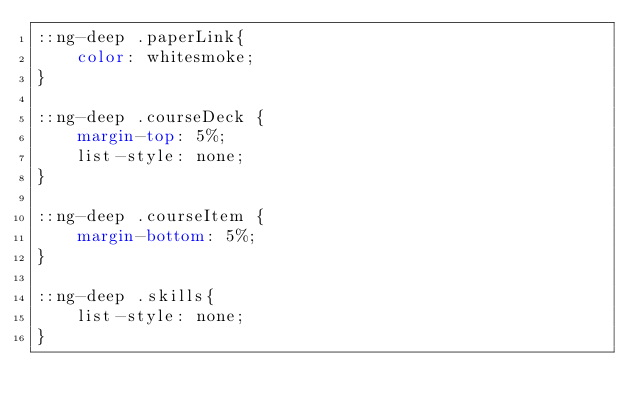<code> <loc_0><loc_0><loc_500><loc_500><_CSS_>::ng-deep .paperLink{
    color: whitesmoke;
}

::ng-deep .courseDeck {
    margin-top: 5%;
    list-style: none;
}

::ng-deep .courseItem {
    margin-bottom: 5%;
}

::ng-deep .skills{
    list-style: none;
}
</code> 